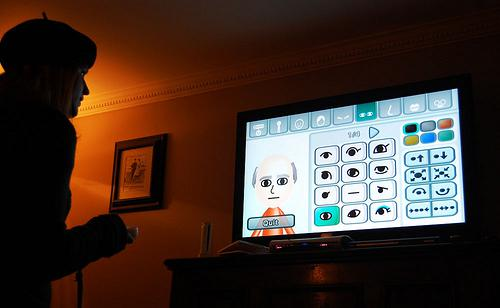Question: what color glow is on the wall?
Choices:
A. Brown.
B. Red.
C. White.
D. Gold.
Answer with the letter. Answer: B Question: why is the man creating the character?
Choices:
A. Comic strip.
B. Cartoon series.
C. Video game.
D. Movie theme.
Answer with the letter. Answer: C Question: where is the TV?
Choices:
A. In the corner.
B. By the bookshelf.
C. On the wall.
D. Near the door.
Answer with the letter. Answer: C Question: who is in front of the TV?
Choices:
A. A woman.
B. A teenager.
C. A child.
D. A man.
Answer with the letter. Answer: D Question: when was the photo taken?
Choices:
A. Day time.
B. Evening.
C. Night time.
D. Morning.
Answer with the letter. Answer: C 